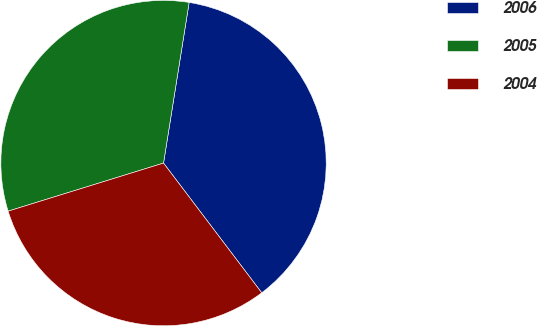Convert chart to OTSL. <chart><loc_0><loc_0><loc_500><loc_500><pie_chart><fcel>2006<fcel>2005<fcel>2004<nl><fcel>37.17%<fcel>32.29%<fcel>30.54%<nl></chart> 